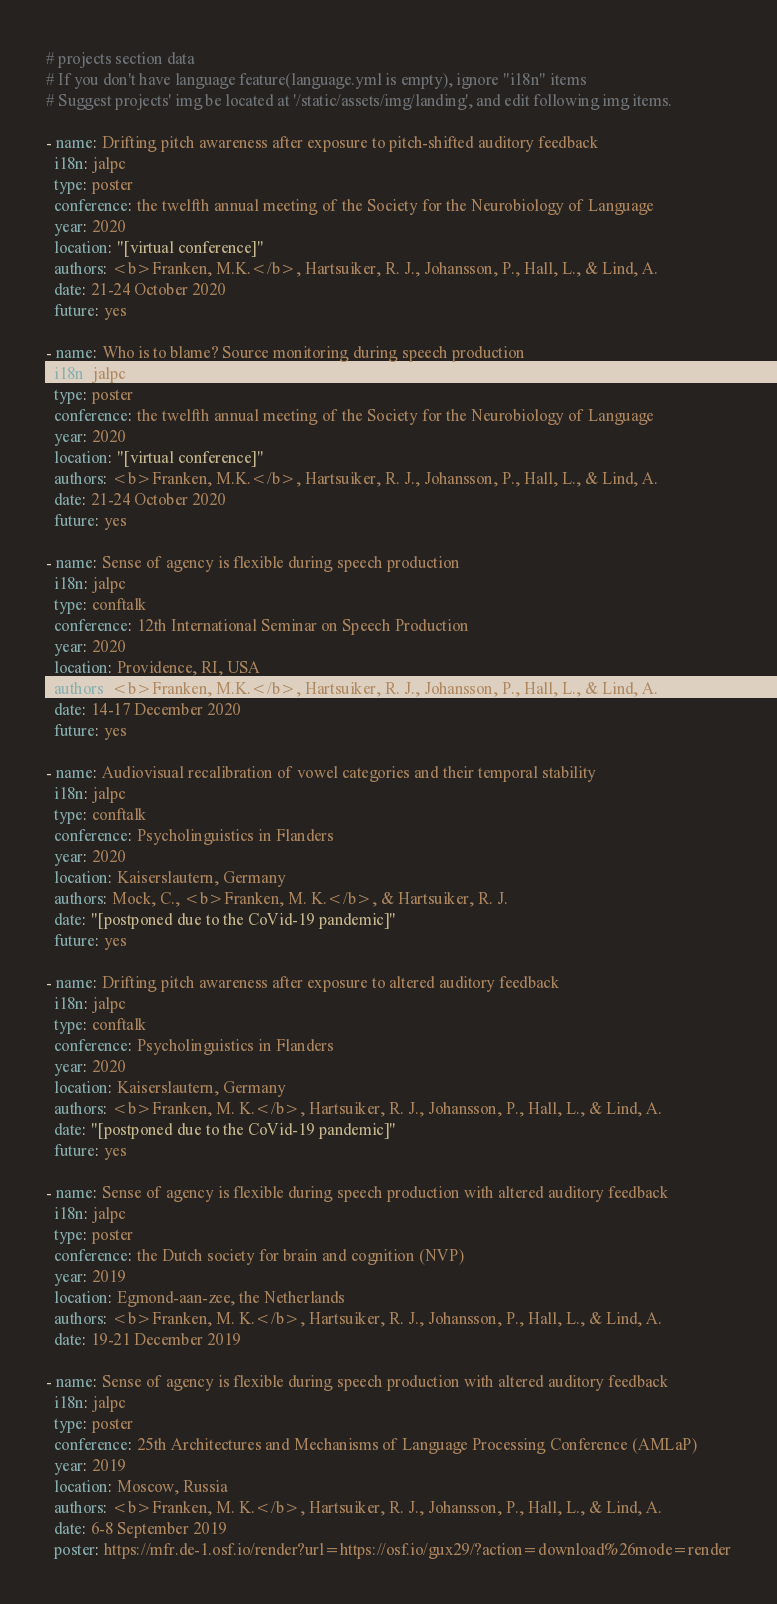Convert code to text. <code><loc_0><loc_0><loc_500><loc_500><_YAML_># projects section data
# If you don't have language feature(language.yml is empty), ignore "i18n" items
# Suggest projects' img be located at '/static/assets/img/landing', and edit following img items.

- name: Drifting pitch awareness after exposure to pitch-shifted auditory feedback
  i18n: jalpc
  type: poster
  conference: the twelfth annual meeting of the Society for the Neurobiology of Language
  year: 2020
  location: "[virtual conference]"
  authors: <b>Franken, M.K.</b>, Hartsuiker, R. J., Johansson, P., Hall, L., & Lind, A.
  date: 21-24 October 2020
  future: yes

- name: Who is to blame? Source monitoring during speech production
  i18n: jalpc
  type: poster
  conference: the twelfth annual meeting of the Society for the Neurobiology of Language
  year: 2020
  location: "[virtual conference]"
  authors: <b>Franken, M.K.</b>, Hartsuiker, R. J., Johansson, P., Hall, L., & Lind, A.
  date: 21-24 October 2020
  future: yes

- name: Sense of agency is flexible during speech production
  i18n: jalpc
  type: conftalk
  conference: 12th International Seminar on Speech Production
  year: 2020
  location: Providence, RI, USA
  authors: <b>Franken, M.K.</b>, Hartsuiker, R. J., Johansson, P., Hall, L., & Lind, A.
  date: 14-17 December 2020
  future: yes

- name: Audiovisual recalibration of vowel categories and their temporal stability
  i18n: jalpc
  type: conftalk
  conference: Psycholinguistics in Flanders
  year: 2020
  location: Kaiserslautern, Germany
  authors: Mock, C., <b>Franken, M. K.</b>, & Hartsuiker, R. J.
  date: "[postponed due to the CoVid-19 pandemic]"
  future: yes

- name: Drifting pitch awareness after exposure to altered auditory feedback
  i18n: jalpc
  type: conftalk
  conference: Psycholinguistics in Flanders
  year: 2020
  location: Kaiserslautern, Germany
  authors: <b>Franken, M. K.</b>, Hartsuiker, R. J., Johansson, P., Hall, L., & Lind, A.
  date: "[postponed due to the CoVid-19 pandemic]"
  future: yes

- name: Sense of agency is flexible during speech production with altered auditory feedback
  i18n: jalpc
  type: poster
  conference: the Dutch society for brain and cognition (NVP)
  year: 2019
  location: Egmond-aan-zee, the Netherlands
  authors: <b>Franken, M. K.</b>, Hartsuiker, R. J., Johansson, P., Hall, L., & Lind, A.
  date: 19-21 December 2019

- name: Sense of agency is flexible during speech production with altered auditory feedback
  i18n: jalpc
  type: poster
  conference: 25th Architectures and Mechanisms of Language Processing Conference (AMLaP)
  year: 2019
  location: Moscow, Russia
  authors: <b>Franken, M. K.</b>, Hartsuiker, R. J., Johansson, P., Hall, L., & Lind, A.
  date: 6-8 September 2019
  poster: https://mfr.de-1.osf.io/render?url=https://osf.io/gux29/?action=download%26mode=render
</code> 